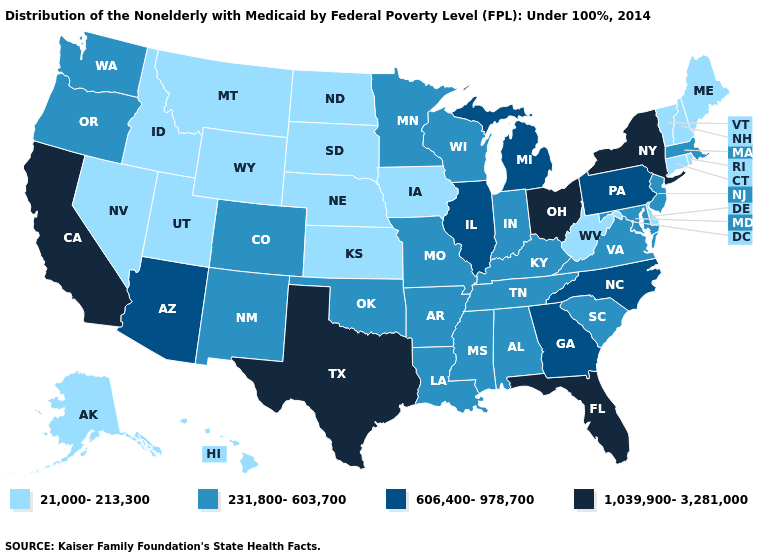Does the first symbol in the legend represent the smallest category?
Be succinct. Yes. What is the lowest value in the Northeast?
Keep it brief. 21,000-213,300. What is the value of Ohio?
Short answer required. 1,039,900-3,281,000. What is the value of New Jersey?
Give a very brief answer. 231,800-603,700. Among the states that border North Dakota , which have the highest value?
Be succinct. Minnesota. What is the lowest value in the South?
Quick response, please. 21,000-213,300. What is the value of Alabama?
Concise answer only. 231,800-603,700. What is the value of Montana?
Short answer required. 21,000-213,300. Name the states that have a value in the range 1,039,900-3,281,000?
Give a very brief answer. California, Florida, New York, Ohio, Texas. Name the states that have a value in the range 1,039,900-3,281,000?
Keep it brief. California, Florida, New York, Ohio, Texas. Name the states that have a value in the range 1,039,900-3,281,000?
Concise answer only. California, Florida, New York, Ohio, Texas. Name the states that have a value in the range 1,039,900-3,281,000?
Quick response, please. California, Florida, New York, Ohio, Texas. What is the value of Minnesota?
Write a very short answer. 231,800-603,700. Name the states that have a value in the range 606,400-978,700?
Write a very short answer. Arizona, Georgia, Illinois, Michigan, North Carolina, Pennsylvania. What is the value of North Carolina?
Short answer required. 606,400-978,700. 